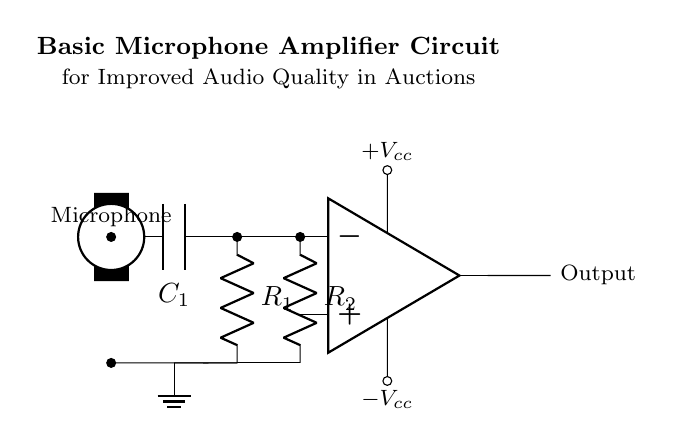What is the type of the main component used in this circuit? The main component is an operational amplifier, commonly used for amplifying audio signals. It takes the signal from the microphone and boosts it for improved output.
Answer: Operational amplifier What is the role of capacitor C1 in the circuit? Capacitor C1 is used for coupling; it allows AC audio signals to pass while blocking DC signals, ensuring that only the desired audio frequency content is amplified.
Answer: Coupling How many resistors are present in the circuit? There are two resistors in the circuit, R1 and R2, which set the gain and assist in the overall signal conditioning process of the amplifier.
Answer: Two What is the purpose of the output node in the circuit? The output node carries the amplified audio signal from the operational amplifier to be sent onwards, typically to speakers or a recording device, enhancing audio quality during the auction.
Answer: Amplified audio signal What do the labels +Vcc and -Vcc signify in the circuit diagram? +Vcc and -Vcc indicate the power supply voltages applied to the operational amplifier, providing the necessary power to operate the amplifier and process incoming signals.
Answer: Power supply voltages How does R2 interact with R1 in this amplifier circuit? R2 provides feedback to the inverting input of the operational amplifier, helping to set the gain of the amplifier based on its value compared to R1; the feedback configuration stabilizes and controls the amplification process.
Answer: Feedback for gain control 